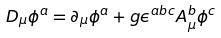Convert formula to latex. <formula><loc_0><loc_0><loc_500><loc_500>D _ { \mu } \phi ^ { a } = \partial _ { \mu } \phi ^ { a } + g \epsilon ^ { a b c } A _ { \mu } ^ { b } \phi ^ { c }</formula> 